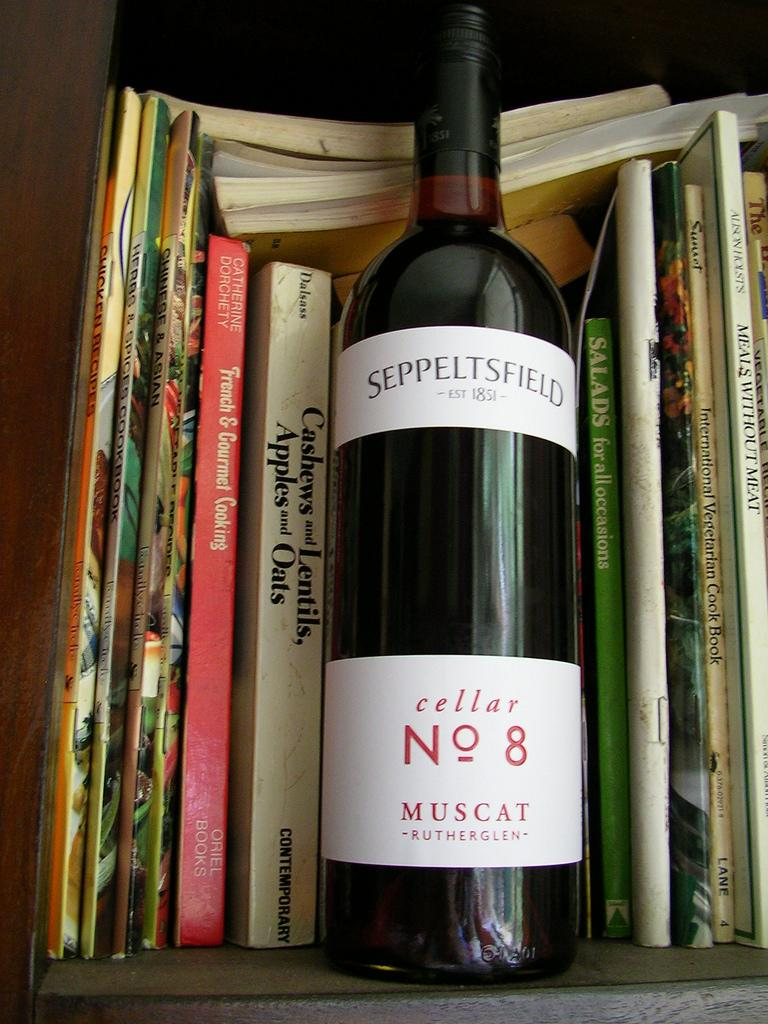<image>
Share a concise interpretation of the image provided. A bottle of muscat is on a shelf surrounded by cook books. 